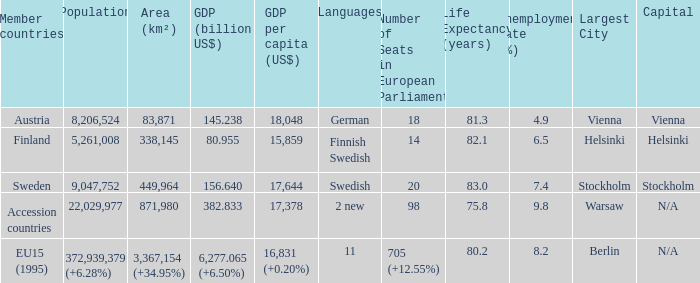Name the member countries for finnish swedish Finland. 